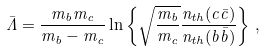Convert formula to latex. <formula><loc_0><loc_0><loc_500><loc_500>\bar { \Lambda } = \frac { m _ { b } m _ { c } } { m _ { b } - m _ { c } } \ln \left \{ \sqrt { \frac { m _ { b } } { m _ { c } } } \frac { n _ { t h } ( c \bar { c } ) } { n _ { t h } ( b \bar { b } ) } \right \} \, ,</formula> 